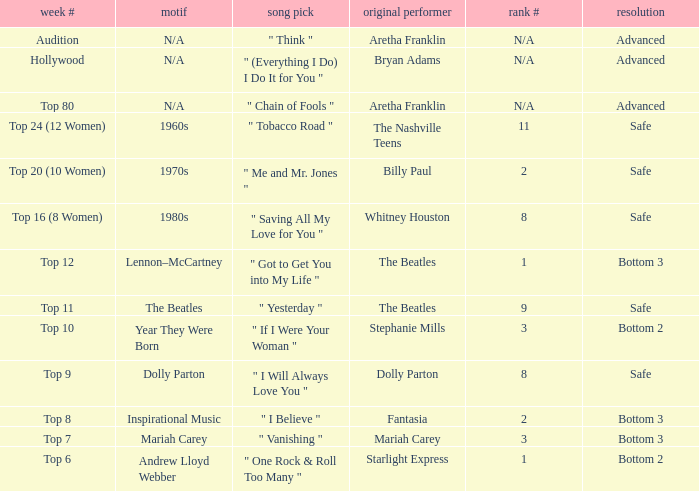Would you be able to parse every entry in this table? {'header': ['week #', 'motif', 'song pick', 'original performer', 'rank #', 'resolution'], 'rows': [['Audition', 'N/A', '" Think "', 'Aretha Franklin', 'N/A', 'Advanced'], ['Hollywood', 'N/A', '" (Everything I Do) I Do It for You "', 'Bryan Adams', 'N/A', 'Advanced'], ['Top 80', 'N/A', '" Chain of Fools "', 'Aretha Franklin', 'N/A', 'Advanced'], ['Top 24 (12 Women)', '1960s', '" Tobacco Road "', 'The Nashville Teens', '11', 'Safe'], ['Top 20 (10 Women)', '1970s', '" Me and Mr. Jones "', 'Billy Paul', '2', 'Safe'], ['Top 16 (8 Women)', '1980s', '" Saving All My Love for You "', 'Whitney Houston', '8', 'Safe'], ['Top 12', 'Lennon–McCartney', '" Got to Get You into My Life "', 'The Beatles', '1', 'Bottom 3'], ['Top 11', 'The Beatles', '" Yesterday "', 'The Beatles', '9', 'Safe'], ['Top 10', 'Year They Were Born', '" If I Were Your Woman "', 'Stephanie Mills', '3', 'Bottom 2'], ['Top 9', 'Dolly Parton', '" I Will Always Love You "', 'Dolly Parton', '8', 'Safe'], ['Top 8', 'Inspirational Music', '" I Believe "', 'Fantasia', '2', 'Bottom 3'], ['Top 7', 'Mariah Carey', '" Vanishing "', 'Mariah Carey', '3', 'Bottom 3'], ['Top 6', 'Andrew Lloyd Webber', '" One Rock & Roll Too Many "', 'Starlight Express', '1', 'Bottom 2']]} Name the week number for andrew lloyd webber Top 6. 